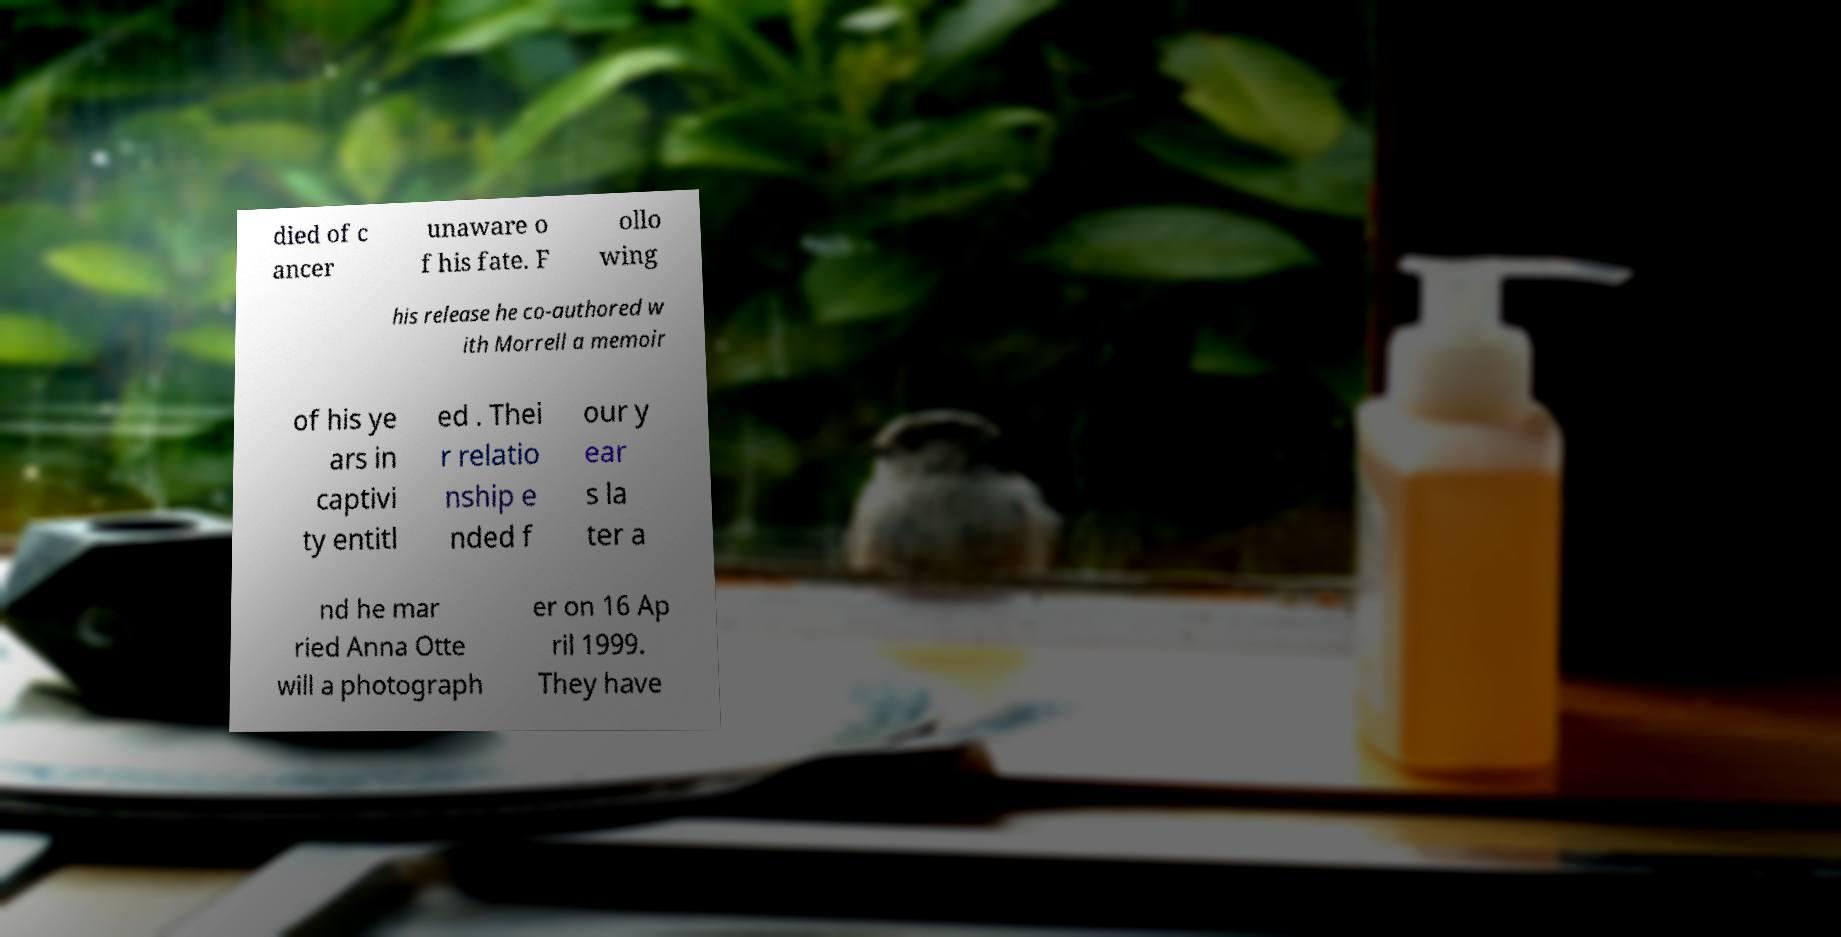For documentation purposes, I need the text within this image transcribed. Could you provide that? died of c ancer unaware o f his fate. F ollo wing his release he co-authored w ith Morrell a memoir of his ye ars in captivi ty entitl ed . Thei r relatio nship e nded f our y ear s la ter a nd he mar ried Anna Otte will a photograph er on 16 Ap ril 1999. They have 